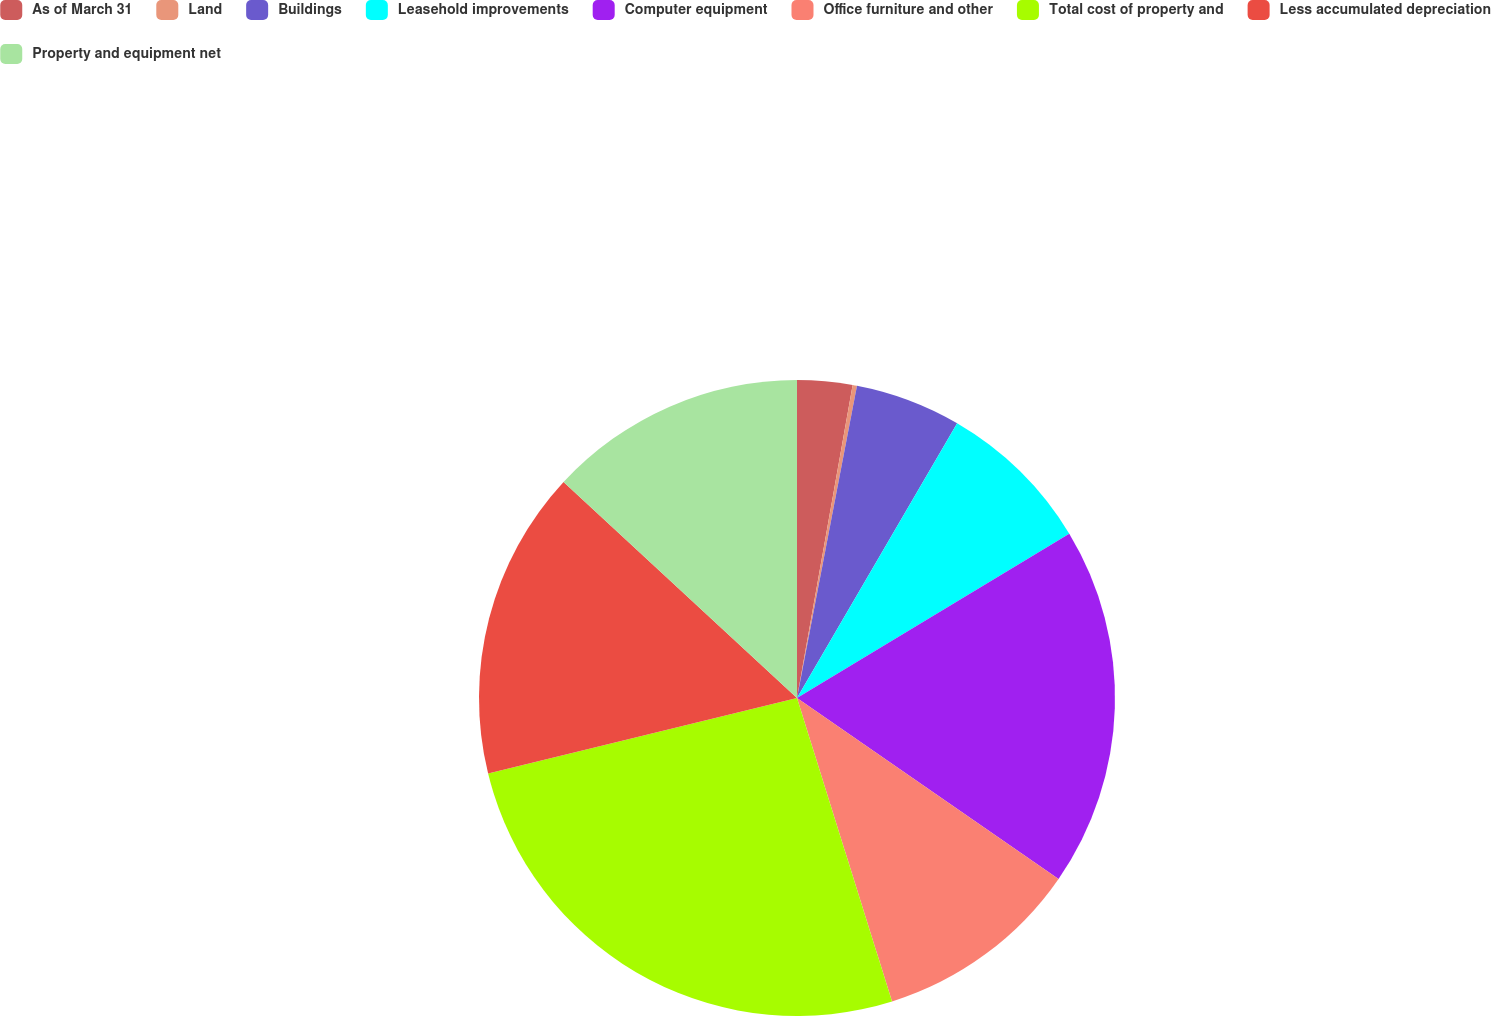Convert chart. <chart><loc_0><loc_0><loc_500><loc_500><pie_chart><fcel>As of March 31<fcel>Land<fcel>Buildings<fcel>Leasehold improvements<fcel>Computer equipment<fcel>Office furniture and other<fcel>Total cost of property and<fcel>Less accumulated depreciation<fcel>Property and equipment net<nl><fcel>2.8%<fcel>0.22%<fcel>5.38%<fcel>7.96%<fcel>18.27%<fcel>10.54%<fcel>26.01%<fcel>15.7%<fcel>13.12%<nl></chart> 